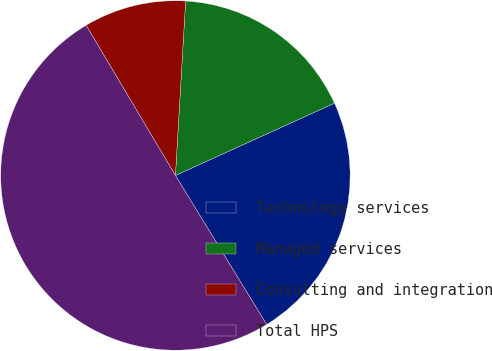Convert chart to OTSL. <chart><loc_0><loc_0><loc_500><loc_500><pie_chart><fcel>Technology services<fcel>Managed services<fcel>Consulting and integration<fcel>Total HPS<nl><fcel>23.05%<fcel>17.28%<fcel>9.47%<fcel>50.21%<nl></chart> 